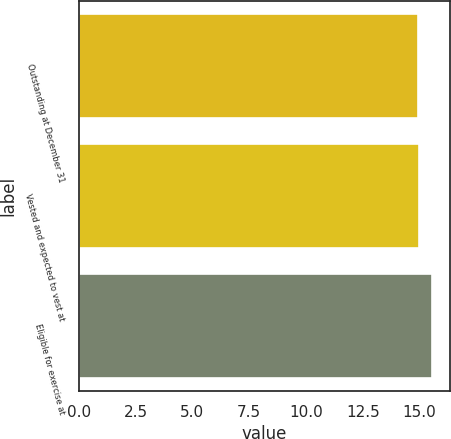Convert chart. <chart><loc_0><loc_0><loc_500><loc_500><bar_chart><fcel>Outstanding at December 31<fcel>Vested and expected to vest at<fcel>Eligible for exercise at<nl><fcel>14.91<fcel>14.97<fcel>15.55<nl></chart> 